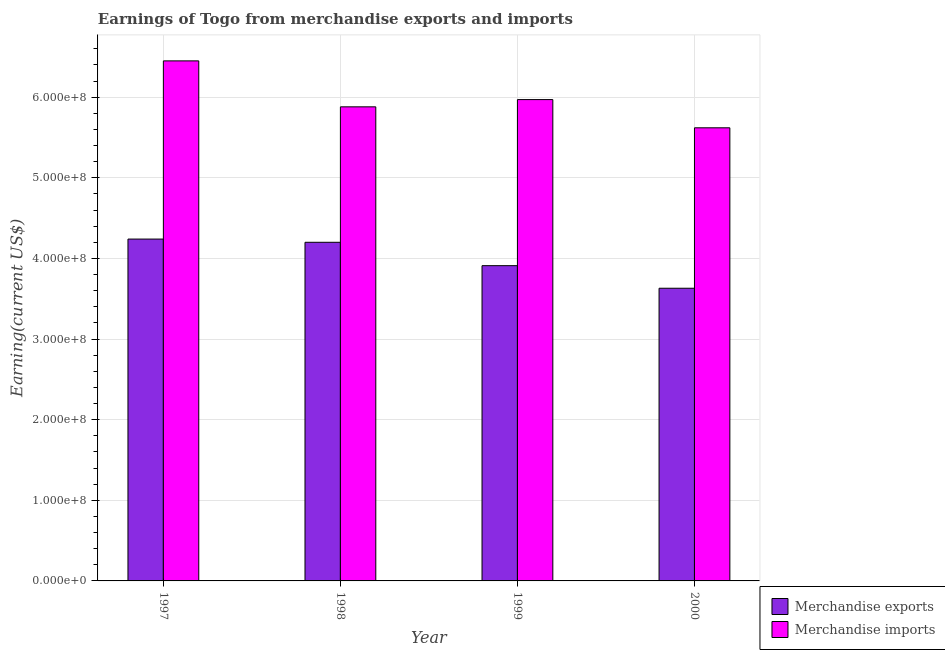How many different coloured bars are there?
Offer a terse response. 2. How many groups of bars are there?
Provide a succinct answer. 4. How many bars are there on the 2nd tick from the left?
Give a very brief answer. 2. What is the label of the 2nd group of bars from the left?
Offer a terse response. 1998. What is the earnings from merchandise exports in 1997?
Provide a succinct answer. 4.24e+08. Across all years, what is the maximum earnings from merchandise imports?
Keep it short and to the point. 6.45e+08. Across all years, what is the minimum earnings from merchandise exports?
Make the answer very short. 3.63e+08. In which year was the earnings from merchandise exports maximum?
Offer a very short reply. 1997. What is the total earnings from merchandise exports in the graph?
Offer a terse response. 1.60e+09. What is the difference between the earnings from merchandise imports in 1999 and that in 2000?
Provide a short and direct response. 3.50e+07. What is the difference between the earnings from merchandise exports in 2000 and the earnings from merchandise imports in 1999?
Provide a short and direct response. -2.80e+07. What is the average earnings from merchandise imports per year?
Provide a short and direct response. 5.98e+08. What is the ratio of the earnings from merchandise imports in 1997 to that in 2000?
Your answer should be compact. 1.15. Is the difference between the earnings from merchandise imports in 1997 and 2000 greater than the difference between the earnings from merchandise exports in 1997 and 2000?
Ensure brevity in your answer.  No. What is the difference between the highest and the second highest earnings from merchandise imports?
Offer a terse response. 4.80e+07. What is the difference between the highest and the lowest earnings from merchandise imports?
Offer a terse response. 8.30e+07. Is the sum of the earnings from merchandise exports in 1999 and 2000 greater than the maximum earnings from merchandise imports across all years?
Your answer should be very brief. Yes. What does the 2nd bar from the left in 1998 represents?
Your answer should be compact. Merchandise imports. What does the 2nd bar from the right in 1997 represents?
Offer a terse response. Merchandise exports. Are all the bars in the graph horizontal?
Ensure brevity in your answer.  No. Are the values on the major ticks of Y-axis written in scientific E-notation?
Provide a short and direct response. Yes. Does the graph contain any zero values?
Your response must be concise. No. How are the legend labels stacked?
Ensure brevity in your answer.  Vertical. What is the title of the graph?
Offer a very short reply. Earnings of Togo from merchandise exports and imports. What is the label or title of the X-axis?
Make the answer very short. Year. What is the label or title of the Y-axis?
Provide a short and direct response. Earning(current US$). What is the Earning(current US$) of Merchandise exports in 1997?
Give a very brief answer. 4.24e+08. What is the Earning(current US$) in Merchandise imports in 1997?
Provide a succinct answer. 6.45e+08. What is the Earning(current US$) of Merchandise exports in 1998?
Provide a succinct answer. 4.20e+08. What is the Earning(current US$) of Merchandise imports in 1998?
Offer a terse response. 5.88e+08. What is the Earning(current US$) of Merchandise exports in 1999?
Your response must be concise. 3.91e+08. What is the Earning(current US$) of Merchandise imports in 1999?
Your response must be concise. 5.97e+08. What is the Earning(current US$) in Merchandise exports in 2000?
Provide a short and direct response. 3.63e+08. What is the Earning(current US$) in Merchandise imports in 2000?
Your answer should be compact. 5.62e+08. Across all years, what is the maximum Earning(current US$) of Merchandise exports?
Keep it short and to the point. 4.24e+08. Across all years, what is the maximum Earning(current US$) of Merchandise imports?
Offer a very short reply. 6.45e+08. Across all years, what is the minimum Earning(current US$) in Merchandise exports?
Offer a terse response. 3.63e+08. Across all years, what is the minimum Earning(current US$) in Merchandise imports?
Provide a short and direct response. 5.62e+08. What is the total Earning(current US$) of Merchandise exports in the graph?
Ensure brevity in your answer.  1.60e+09. What is the total Earning(current US$) in Merchandise imports in the graph?
Your response must be concise. 2.39e+09. What is the difference between the Earning(current US$) in Merchandise exports in 1997 and that in 1998?
Your response must be concise. 4.00e+06. What is the difference between the Earning(current US$) in Merchandise imports in 1997 and that in 1998?
Provide a short and direct response. 5.70e+07. What is the difference between the Earning(current US$) in Merchandise exports in 1997 and that in 1999?
Offer a terse response. 3.30e+07. What is the difference between the Earning(current US$) of Merchandise imports in 1997 and that in 1999?
Provide a succinct answer. 4.80e+07. What is the difference between the Earning(current US$) of Merchandise exports in 1997 and that in 2000?
Ensure brevity in your answer.  6.10e+07. What is the difference between the Earning(current US$) in Merchandise imports in 1997 and that in 2000?
Ensure brevity in your answer.  8.30e+07. What is the difference between the Earning(current US$) of Merchandise exports in 1998 and that in 1999?
Make the answer very short. 2.90e+07. What is the difference between the Earning(current US$) of Merchandise imports in 1998 and that in 1999?
Provide a short and direct response. -9.00e+06. What is the difference between the Earning(current US$) of Merchandise exports in 1998 and that in 2000?
Make the answer very short. 5.70e+07. What is the difference between the Earning(current US$) in Merchandise imports in 1998 and that in 2000?
Offer a very short reply. 2.60e+07. What is the difference between the Earning(current US$) of Merchandise exports in 1999 and that in 2000?
Ensure brevity in your answer.  2.80e+07. What is the difference between the Earning(current US$) of Merchandise imports in 1999 and that in 2000?
Offer a very short reply. 3.50e+07. What is the difference between the Earning(current US$) in Merchandise exports in 1997 and the Earning(current US$) in Merchandise imports in 1998?
Your answer should be very brief. -1.64e+08. What is the difference between the Earning(current US$) of Merchandise exports in 1997 and the Earning(current US$) of Merchandise imports in 1999?
Offer a very short reply. -1.73e+08. What is the difference between the Earning(current US$) of Merchandise exports in 1997 and the Earning(current US$) of Merchandise imports in 2000?
Keep it short and to the point. -1.38e+08. What is the difference between the Earning(current US$) in Merchandise exports in 1998 and the Earning(current US$) in Merchandise imports in 1999?
Your answer should be compact. -1.77e+08. What is the difference between the Earning(current US$) in Merchandise exports in 1998 and the Earning(current US$) in Merchandise imports in 2000?
Make the answer very short. -1.42e+08. What is the difference between the Earning(current US$) of Merchandise exports in 1999 and the Earning(current US$) of Merchandise imports in 2000?
Keep it short and to the point. -1.71e+08. What is the average Earning(current US$) in Merchandise exports per year?
Provide a succinct answer. 4.00e+08. What is the average Earning(current US$) in Merchandise imports per year?
Keep it short and to the point. 5.98e+08. In the year 1997, what is the difference between the Earning(current US$) in Merchandise exports and Earning(current US$) in Merchandise imports?
Your response must be concise. -2.21e+08. In the year 1998, what is the difference between the Earning(current US$) in Merchandise exports and Earning(current US$) in Merchandise imports?
Your answer should be compact. -1.68e+08. In the year 1999, what is the difference between the Earning(current US$) of Merchandise exports and Earning(current US$) of Merchandise imports?
Your response must be concise. -2.06e+08. In the year 2000, what is the difference between the Earning(current US$) of Merchandise exports and Earning(current US$) of Merchandise imports?
Ensure brevity in your answer.  -1.99e+08. What is the ratio of the Earning(current US$) in Merchandise exports in 1997 to that in 1998?
Keep it short and to the point. 1.01. What is the ratio of the Earning(current US$) in Merchandise imports in 1997 to that in 1998?
Offer a terse response. 1.1. What is the ratio of the Earning(current US$) of Merchandise exports in 1997 to that in 1999?
Offer a very short reply. 1.08. What is the ratio of the Earning(current US$) in Merchandise imports in 1997 to that in 1999?
Offer a very short reply. 1.08. What is the ratio of the Earning(current US$) of Merchandise exports in 1997 to that in 2000?
Your answer should be very brief. 1.17. What is the ratio of the Earning(current US$) in Merchandise imports in 1997 to that in 2000?
Offer a terse response. 1.15. What is the ratio of the Earning(current US$) in Merchandise exports in 1998 to that in 1999?
Your answer should be compact. 1.07. What is the ratio of the Earning(current US$) in Merchandise imports in 1998 to that in 1999?
Provide a succinct answer. 0.98. What is the ratio of the Earning(current US$) of Merchandise exports in 1998 to that in 2000?
Keep it short and to the point. 1.16. What is the ratio of the Earning(current US$) of Merchandise imports in 1998 to that in 2000?
Your answer should be very brief. 1.05. What is the ratio of the Earning(current US$) in Merchandise exports in 1999 to that in 2000?
Offer a terse response. 1.08. What is the ratio of the Earning(current US$) in Merchandise imports in 1999 to that in 2000?
Provide a succinct answer. 1.06. What is the difference between the highest and the second highest Earning(current US$) of Merchandise imports?
Provide a short and direct response. 4.80e+07. What is the difference between the highest and the lowest Earning(current US$) of Merchandise exports?
Ensure brevity in your answer.  6.10e+07. What is the difference between the highest and the lowest Earning(current US$) in Merchandise imports?
Provide a short and direct response. 8.30e+07. 